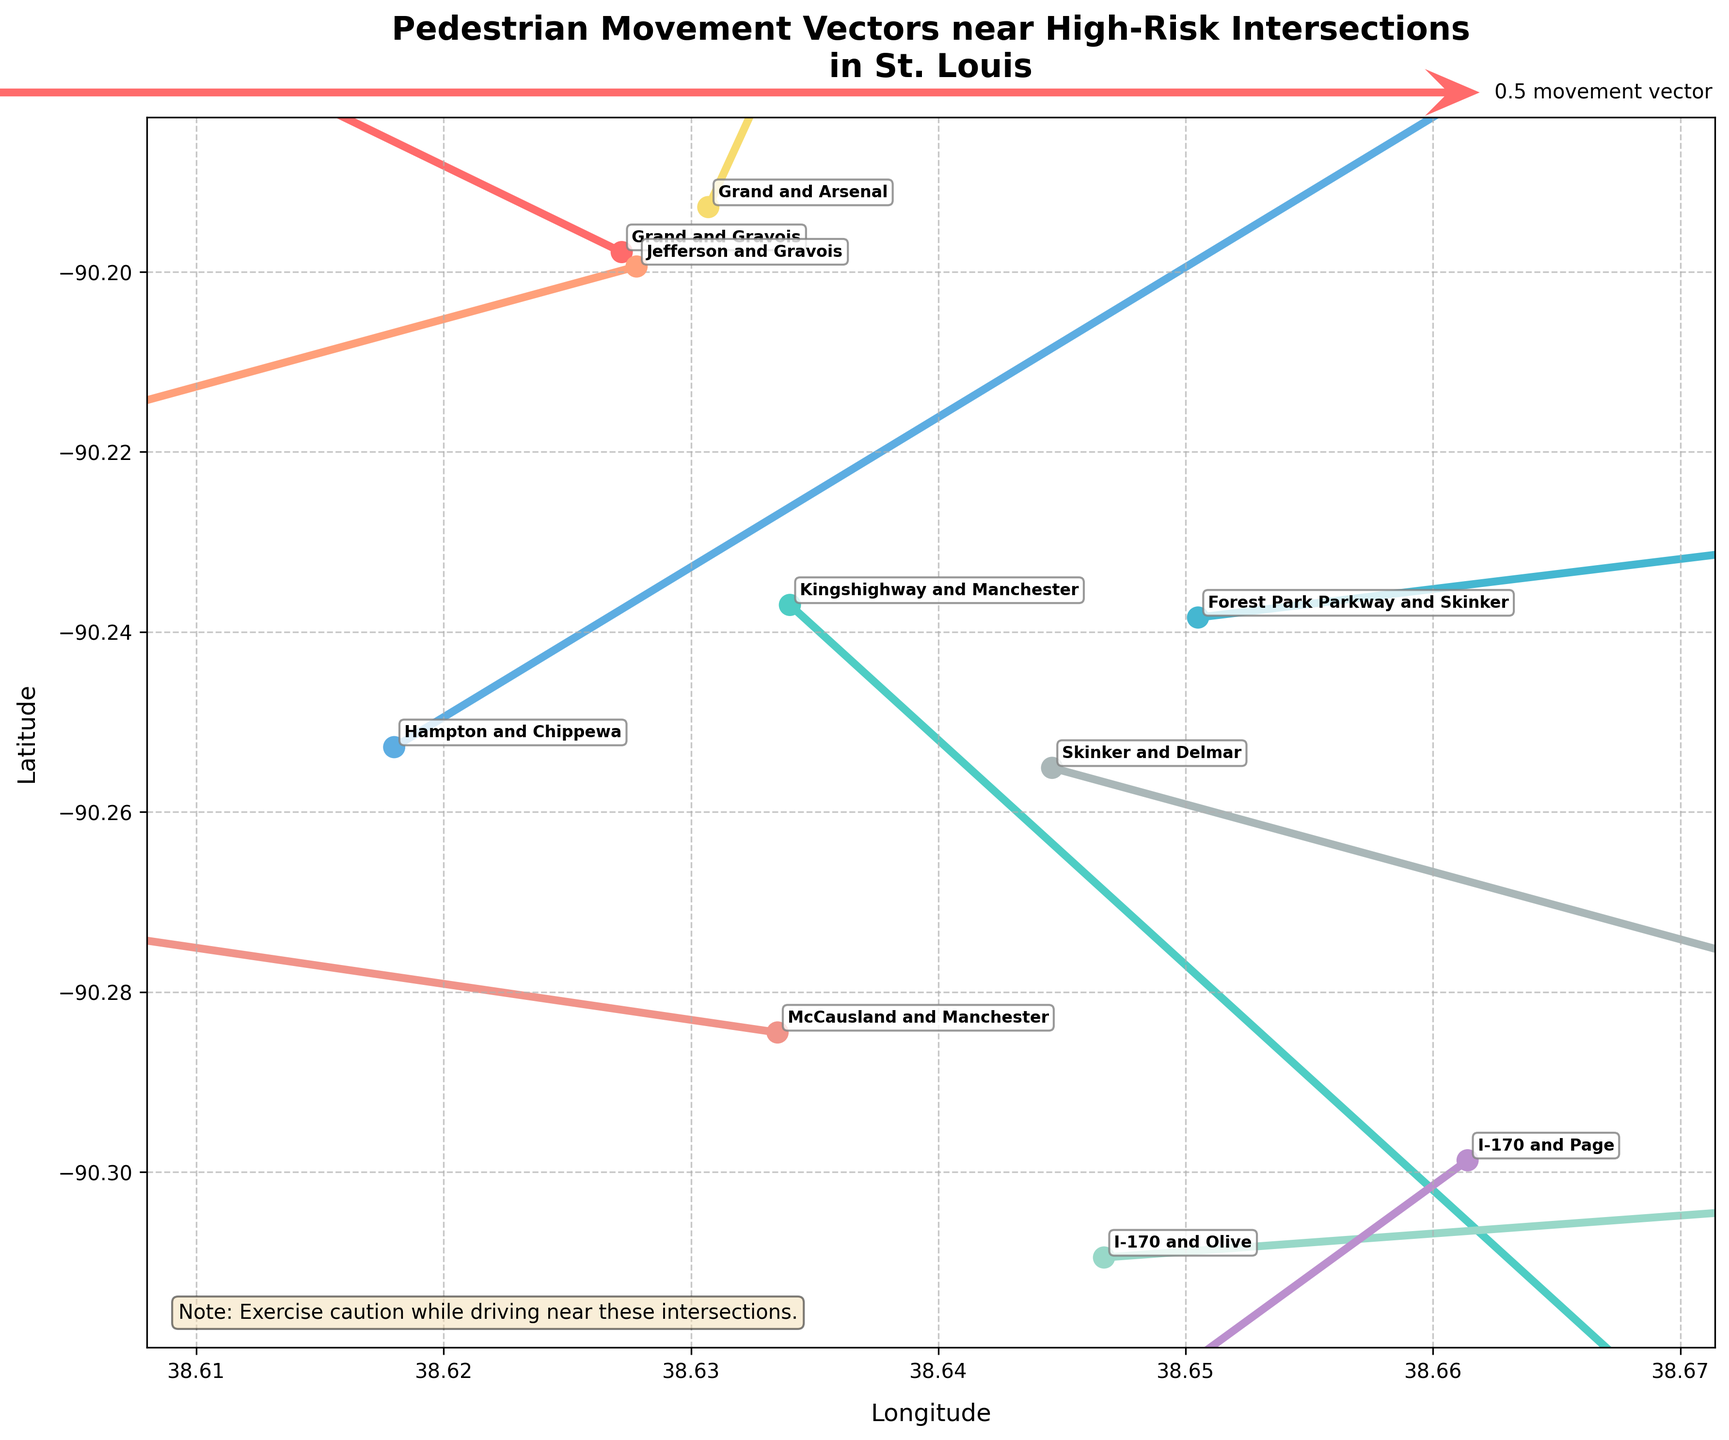What's the title of the figure? The title is located at the top of the figure, which summarizes the main subject.
Answer: Pedestrian Movement Vectors near High-Risk Intersections in St. Louis How many intersections are being analyzed in the plot? By counting the annotation texts around the data points, each representing an intersection, we see there are ten intersections.
Answer: Ten What is the general direction of pedestrian movement at the 'Grand and Arsenal' intersection? Look at the vector (arrow) originating from the 'Grand and Arsenal' intersection; its direction indicates general movement.
Answer: Upward right Which intersection has the most significant downward movement vector? Identify the vector with the largest downward component by comparing their v-values. 'Kingshighway and Manchester' has a v-value of -0.5, which is the most significant downward movement.
Answer: Kingshighway and Manchester Which intersection has a movement vector suggesting a northwest movement? A vector indicating northwest movement must point to the upper-left direction, meaning both u and v values would be negative. 'Jefferson and Gravois' intersection has a vector with both negative u and v values.
Answer: Jefferson and Gravois Compare the movement vectors at 'Forest Park Parkway and Skinker' and 'Skinker and Delmar'. Which one shows a stronger overall movement vector? Calculate the magnitude of the movement vectors for both intersections by using the formula √(u² + v²).
Answer: Forest Park Parkway and Skinker What is the color of the vector at the 'Hampton and Chippewa' intersection? The color of each vector is unique and can be identified by looking at the corresponding legend or directly at the figure. The vector at 'Hampton and Chippewa' is designated by a specific color from the custom palette.
Answer: Cyan What intersections have positive u and v values in their movement vectors, indicating movement towards the northeast? Intersections with both u and v positive components suggest northeast movement; these can be identified by checking the data for vectors with positive components in both directions.
Answer: Grand and Arsenal, Hampton and Chippewa What safety recommendation is mentioned in the figure? Look for any additional text outside the main plot, labeled as a note or recommendation. Often included for reader's alertness and safety.
Answer: Exercise caution while driving near these intersections Compare the movement vector lengths for 'I-170 and Olive' and 'McCausland and Manchester'. Which is longer and by how much? Calculate the vector lengths using √(u² + v²) for both intersections and then compare the results.
Answer: I-170 and Olive, by approximately 0.509 